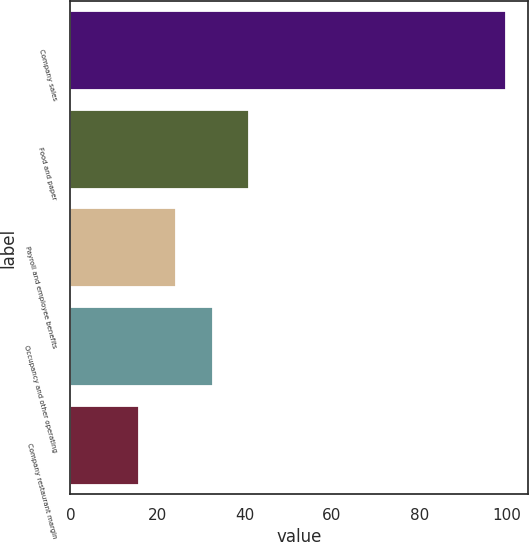Convert chart. <chart><loc_0><loc_0><loc_500><loc_500><bar_chart><fcel>Company sales<fcel>Food and paper<fcel>Payroll and employee benefits<fcel>Occupancy and other operating<fcel>Company restaurant margin<nl><fcel>100<fcel>41.06<fcel>24.22<fcel>32.64<fcel>15.8<nl></chart> 